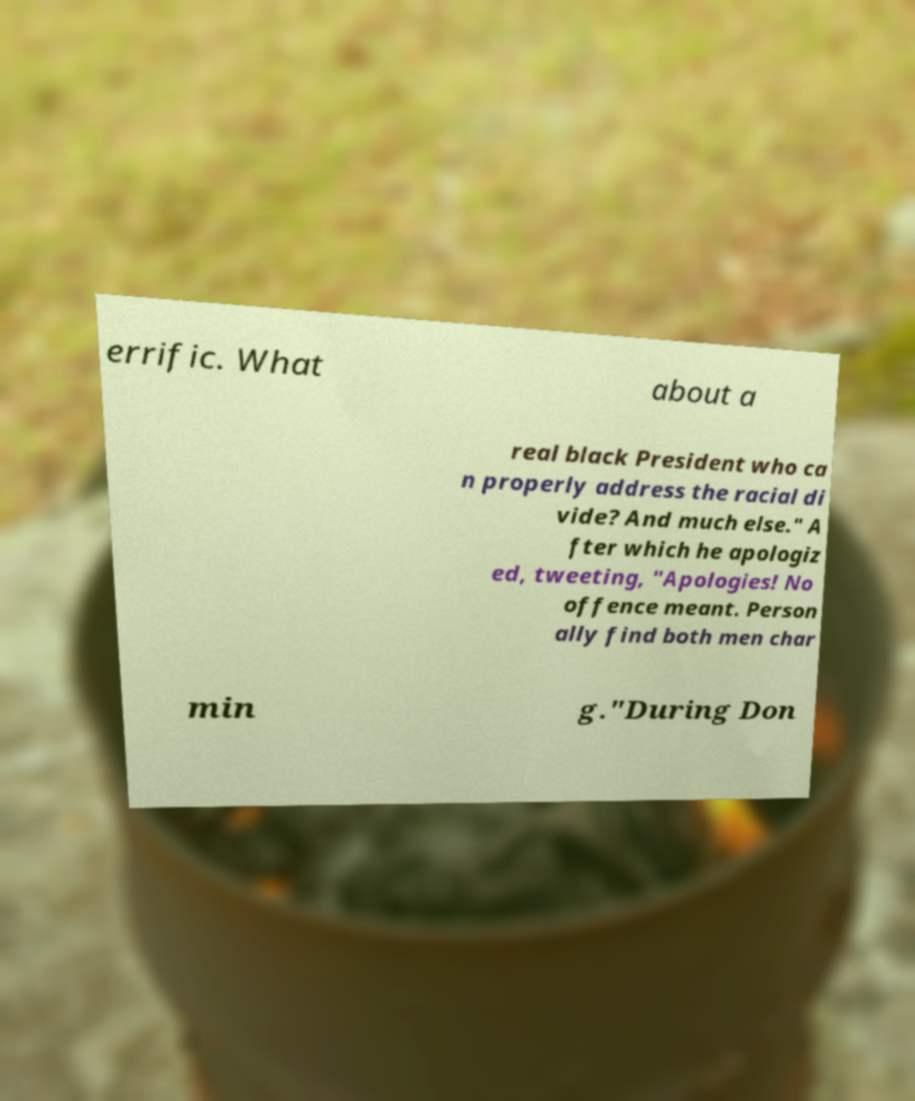Could you assist in decoding the text presented in this image and type it out clearly? errific. What about a real black President who ca n properly address the racial di vide? And much else." A fter which he apologiz ed, tweeting, "Apologies! No offence meant. Person ally find both men char min g."During Don 